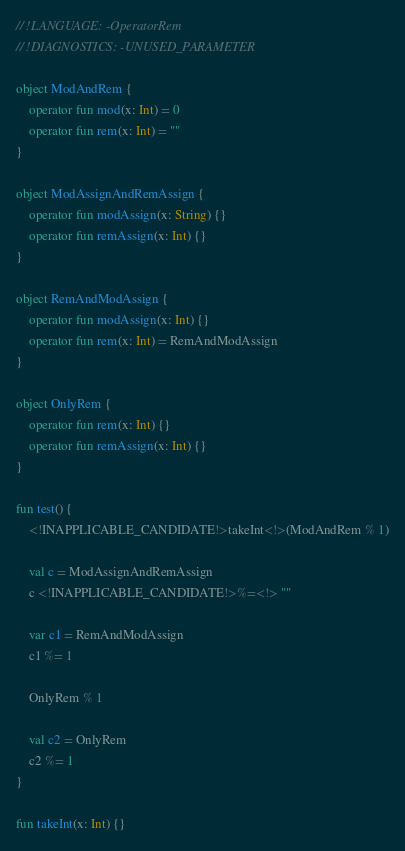<code> <loc_0><loc_0><loc_500><loc_500><_Kotlin_>// !LANGUAGE: -OperatorRem
// !DIAGNOSTICS: -UNUSED_PARAMETER

object ModAndRem {
    operator fun mod(x: Int) = 0
    operator fun rem(x: Int) = ""
}

object ModAssignAndRemAssign {
    operator fun modAssign(x: String) {}
    operator fun remAssign(x: Int) {}
}

object RemAndModAssign {
    operator fun modAssign(x: Int) {}
    operator fun rem(x: Int) = RemAndModAssign
}

object OnlyRem {
    operator fun rem(x: Int) {}
    operator fun remAssign(x: Int) {}
}

fun test() {
    <!INAPPLICABLE_CANDIDATE!>takeInt<!>(ModAndRem % 1)

    val c = ModAssignAndRemAssign
    c <!INAPPLICABLE_CANDIDATE!>%=<!> ""

    var c1 = RemAndModAssign
    c1 %= 1

    OnlyRem % 1

    val c2 = OnlyRem
    c2 %= 1
}

fun takeInt(x: Int) {}
</code> 